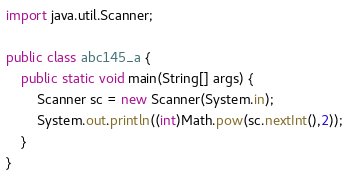<code> <loc_0><loc_0><loc_500><loc_500><_Java_>import java.util.Scanner;

public class abc145_a {
    public static void main(String[] args) {
        Scanner sc = new Scanner(System.in);
        System.out.println((int)Math.pow(sc.nextInt(),2));
    }
}
</code> 